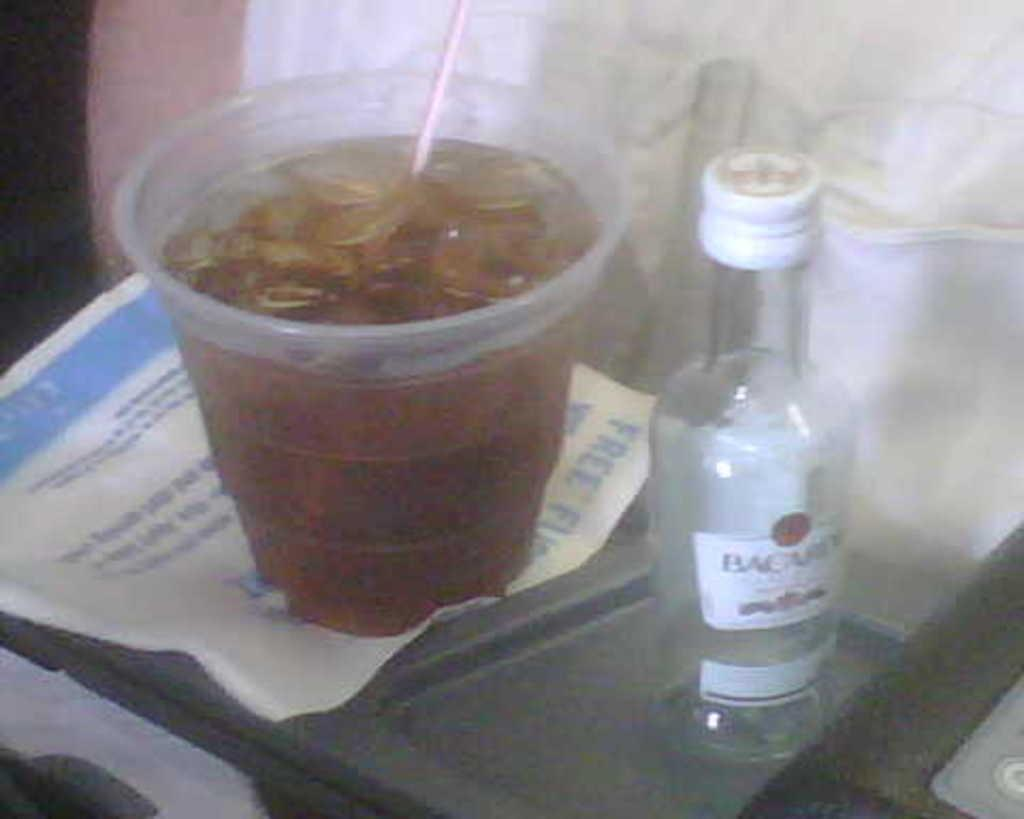<image>
Share a concise interpretation of the image provided. A tray with a glass and a Bacardi bottle on top of it. 